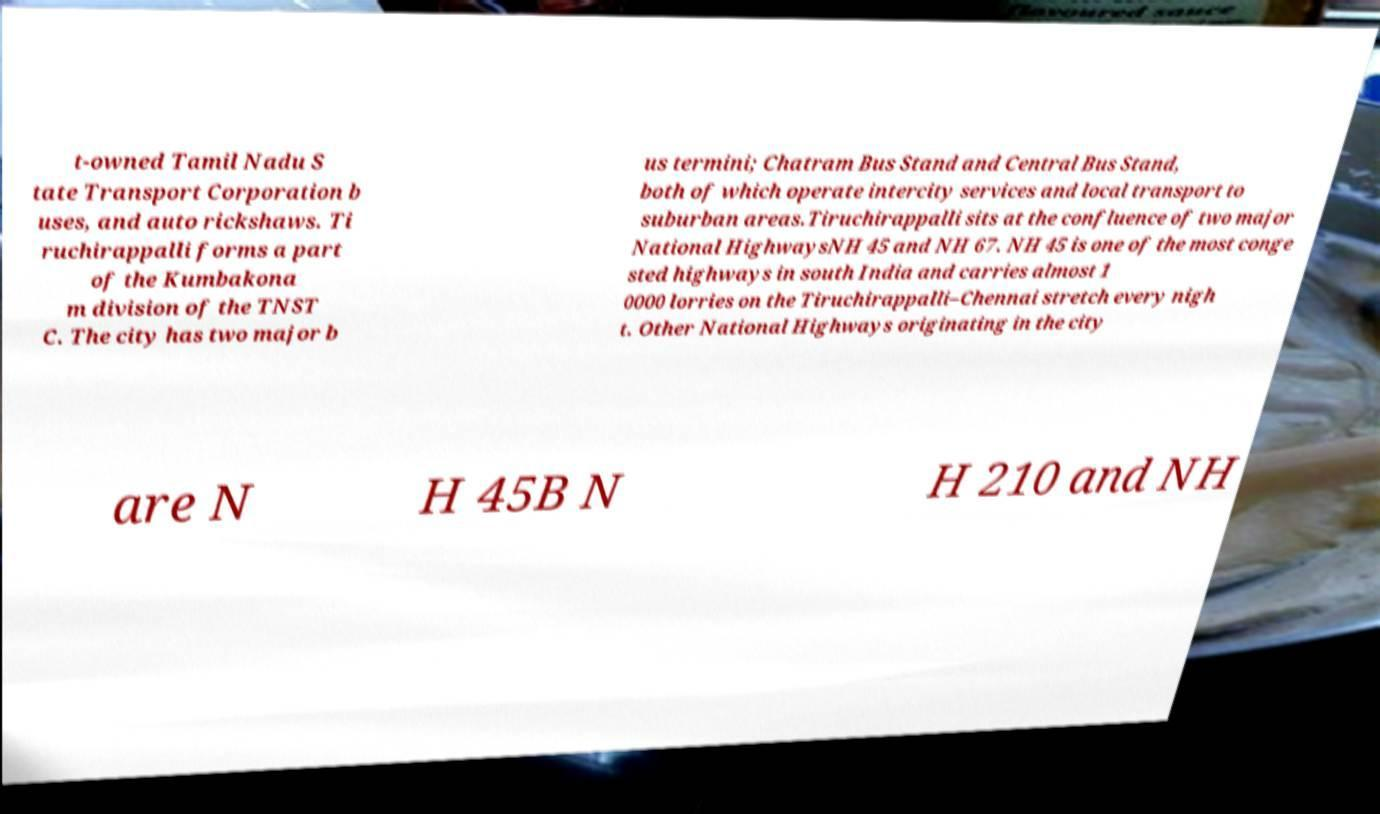Can you accurately transcribe the text from the provided image for me? t-owned Tamil Nadu S tate Transport Corporation b uses, and auto rickshaws. Ti ruchirappalli forms a part of the Kumbakona m division of the TNST C. The city has two major b us termini; Chatram Bus Stand and Central Bus Stand, both of which operate intercity services and local transport to suburban areas.Tiruchirappalli sits at the confluence of two major National HighwaysNH 45 and NH 67. NH 45 is one of the most conge sted highways in south India and carries almost 1 0000 lorries on the Tiruchirappalli–Chennai stretch every nigh t. Other National Highways originating in the city are N H 45B N H 210 and NH 